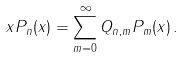<formula> <loc_0><loc_0><loc_500><loc_500>x P _ { n } ( x ) = \sum _ { m = 0 } ^ { \infty } Q _ { n , m } P _ { m } ( x ) \, .</formula> 